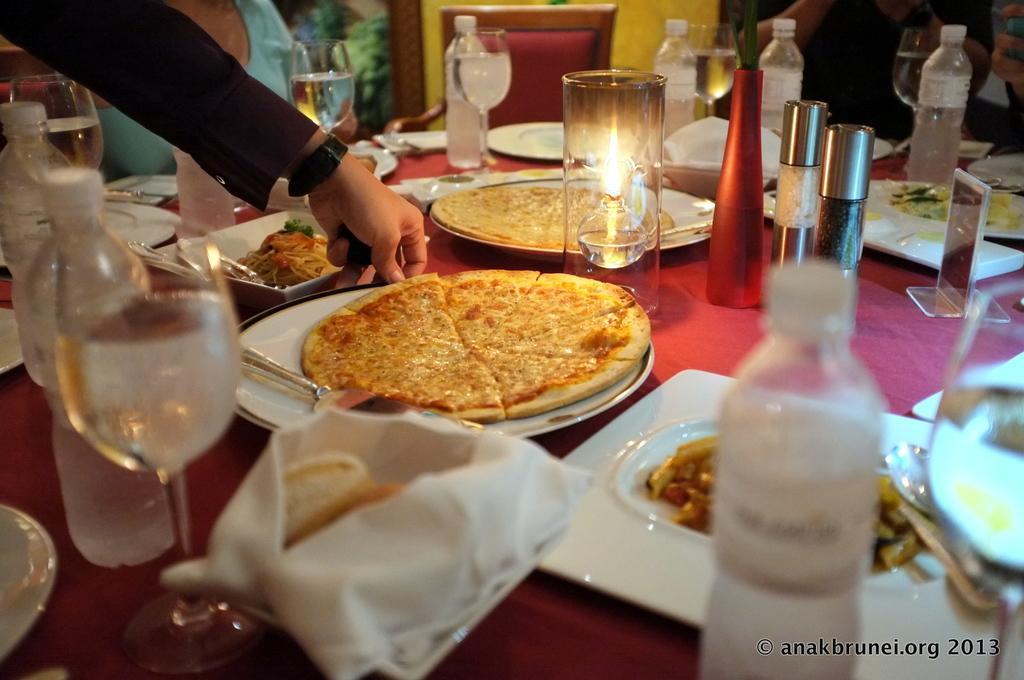Could you give a brief overview of what you see in this image? In this image, I can see the wine glasses, bottles, candle, napkins, food items, plates and few other things on a table. At the bottom right side of the image, I can see a watermark. At the top left side of the image, I can see a person´s hand. In the background, there are two persons and I can see a chair. 